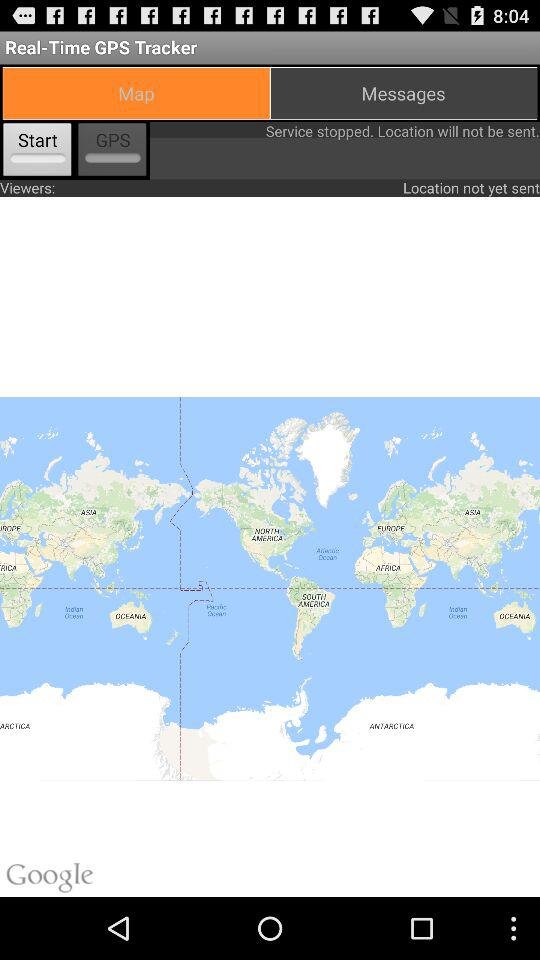What is the selected tab? The selected tab is "Map". 